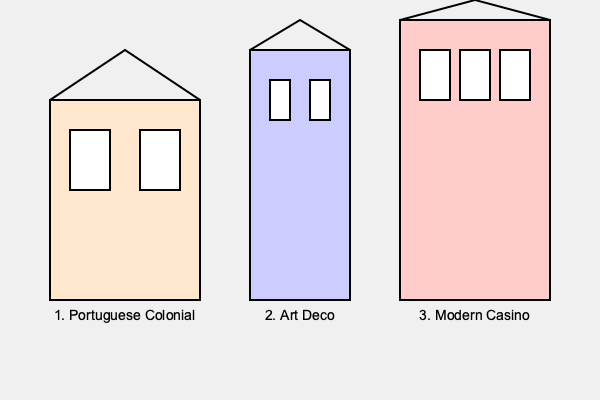In the collage above, which architectural style represents the earliest period of Macau's history and development? To answer this question, we need to consider the historical development of Macau's architecture:

1. Portuguese Colonial style: This style dates back to the 16th century when the Portuguese first settled in Macau. It is characterized by simple, symmetrical designs with whitewashed walls, red tile roofs, and often features balconies and shuttered windows. In the image, building 1 represents this style.

2. Art Deco style: This style became popular in the 1920s and 1930s. It features geometric shapes, stepped facades, and decorative elements. Building 2 in the image represents this style.

3. Modern Casino style: This is the most recent architectural style in Macau, becoming prominent in the late 20th and early 21st centuries with the boom of the gambling industry. It often involves large-scale, flashy designs with glass and steel. Building 3 in the image represents this style.

Among these three styles, the Portuguese Colonial style is the earliest, dating back to the beginning of Macau's colonial period in the 16th century. It represents the earliest period of Macau's history and development as a Portuguese settlement.
Answer: Portuguese Colonial 